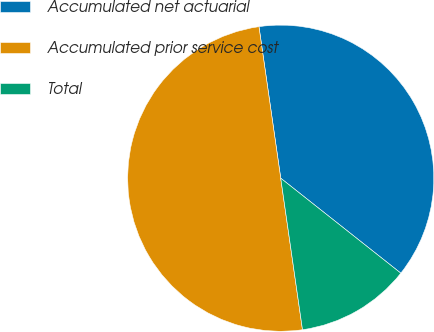Convert chart. <chart><loc_0><loc_0><loc_500><loc_500><pie_chart><fcel>Accumulated net actuarial<fcel>Accumulated prior service cost<fcel>Total<nl><fcel>37.92%<fcel>50.0%<fcel>12.08%<nl></chart> 